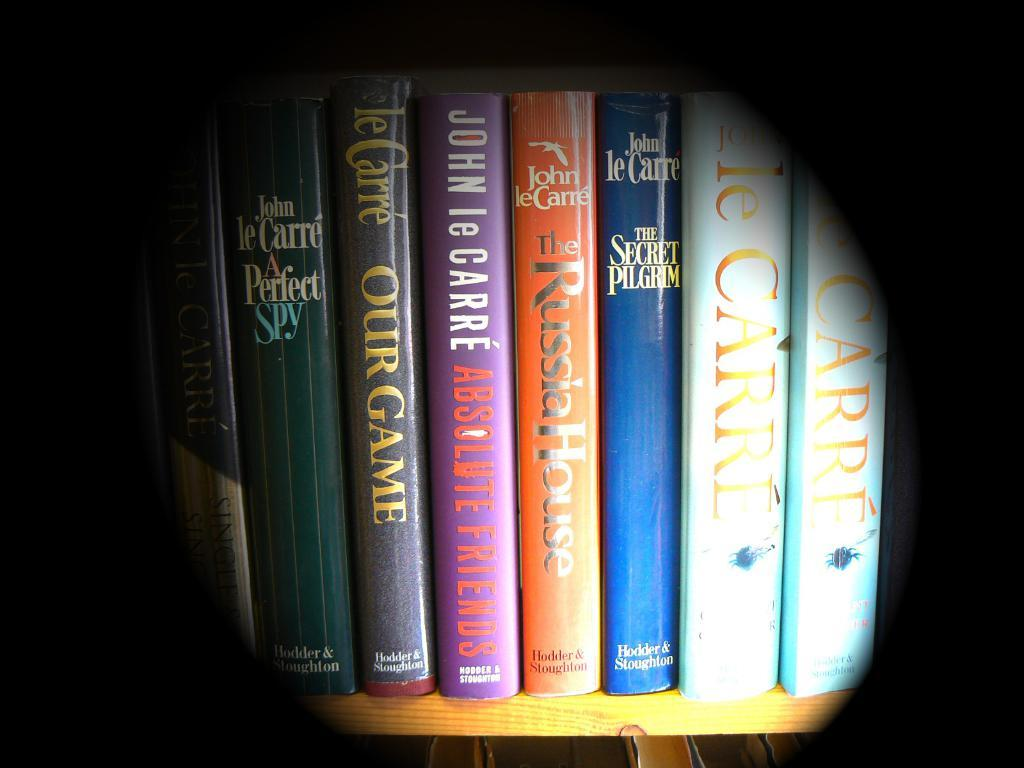<image>
Provide a brief description of the given image. A book titled Our Game is on a shelf with others. 